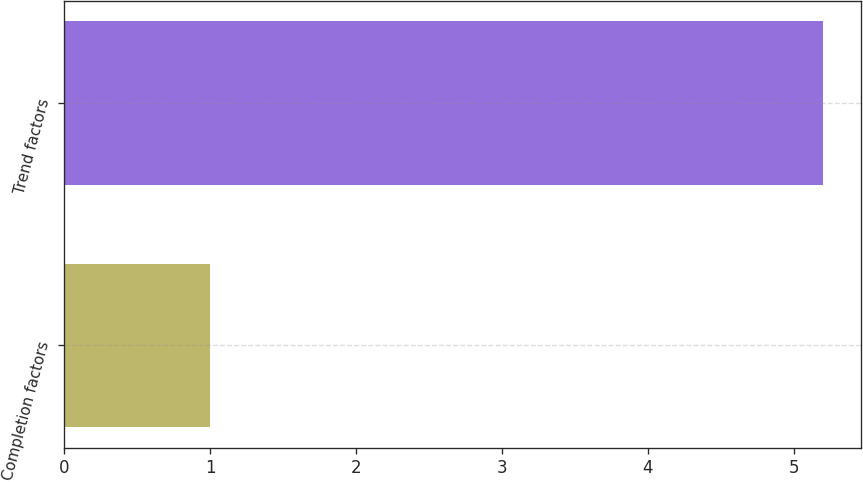Convert chart to OTSL. <chart><loc_0><loc_0><loc_500><loc_500><bar_chart><fcel>Completion factors<fcel>Trend factors<nl><fcel>1<fcel>5.2<nl></chart> 